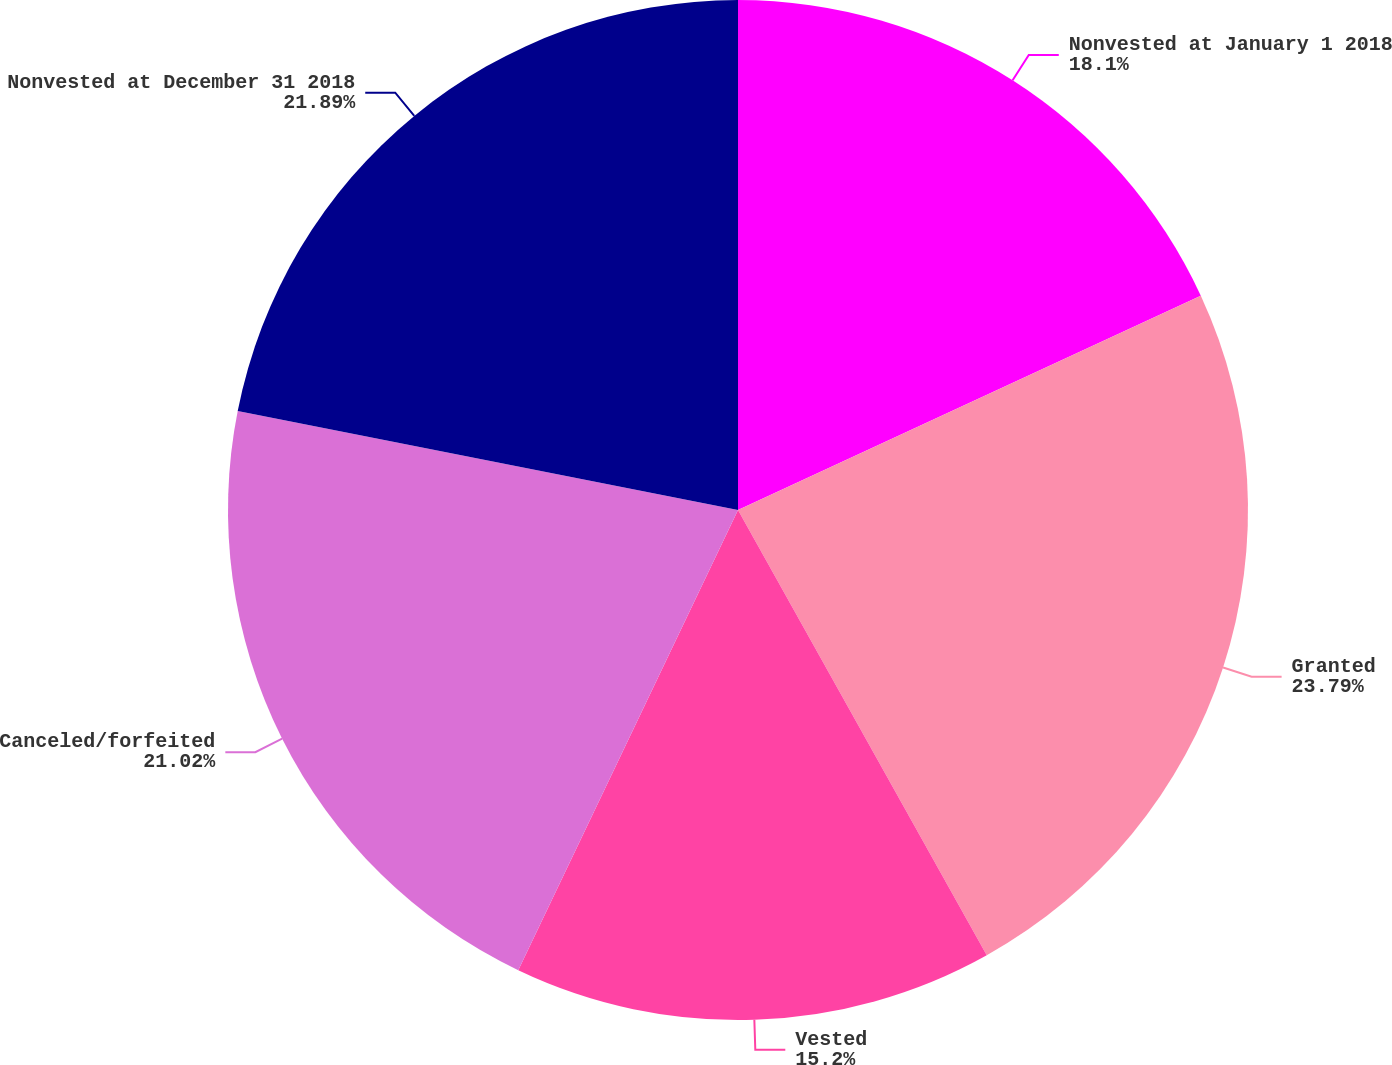<chart> <loc_0><loc_0><loc_500><loc_500><pie_chart><fcel>Nonvested at January 1 2018<fcel>Granted<fcel>Vested<fcel>Canceled/forfeited<fcel>Nonvested at December 31 2018<nl><fcel>18.1%<fcel>23.79%<fcel>15.2%<fcel>21.02%<fcel>21.89%<nl></chart> 